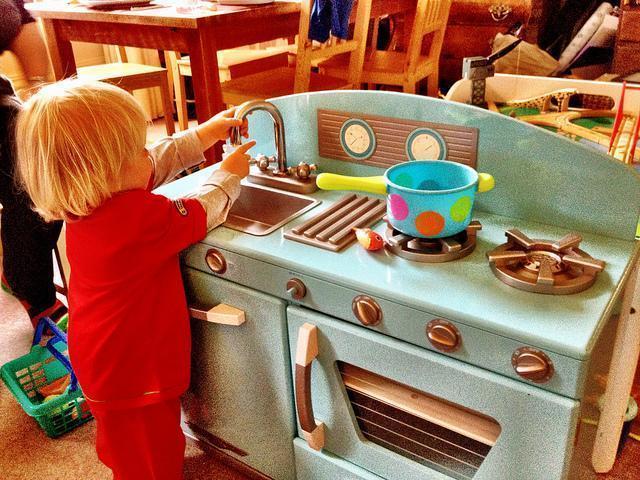What will come out of the sink?
Answer the question by selecting the correct answer among the 4 following choices and explain your choice with a short sentence. The answer should be formatted with the following format: `Answer: choice
Rationale: rationale.`
Options: Water, nothing, gasoline, soda. Answer: nothing.
Rationale: The play stove does not have a real water source. 